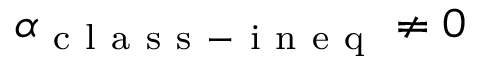Convert formula to latex. <formula><loc_0><loc_0><loc_500><loc_500>\alpha _ { c l a s s - i n e q } \neq 0</formula> 